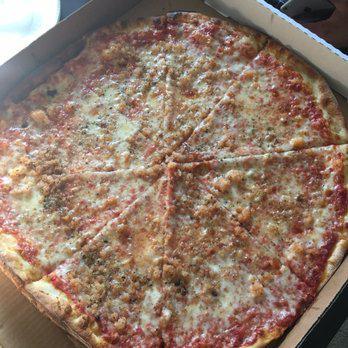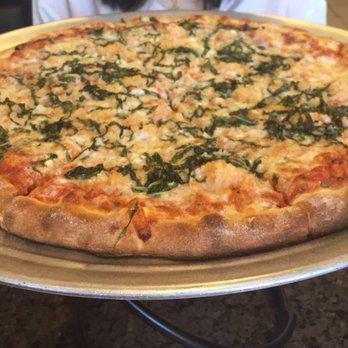The first image is the image on the left, the second image is the image on the right. Analyze the images presented: Is the assertion "A wedge-shaped slice is missing from a deep-dish round 'pie' in one image." valid? Answer yes or no. No. The first image is the image on the left, the second image is the image on the right. Analyze the images presented: Is the assertion "In one of the images a piece of pizza pie is missing." valid? Answer yes or no. No. 